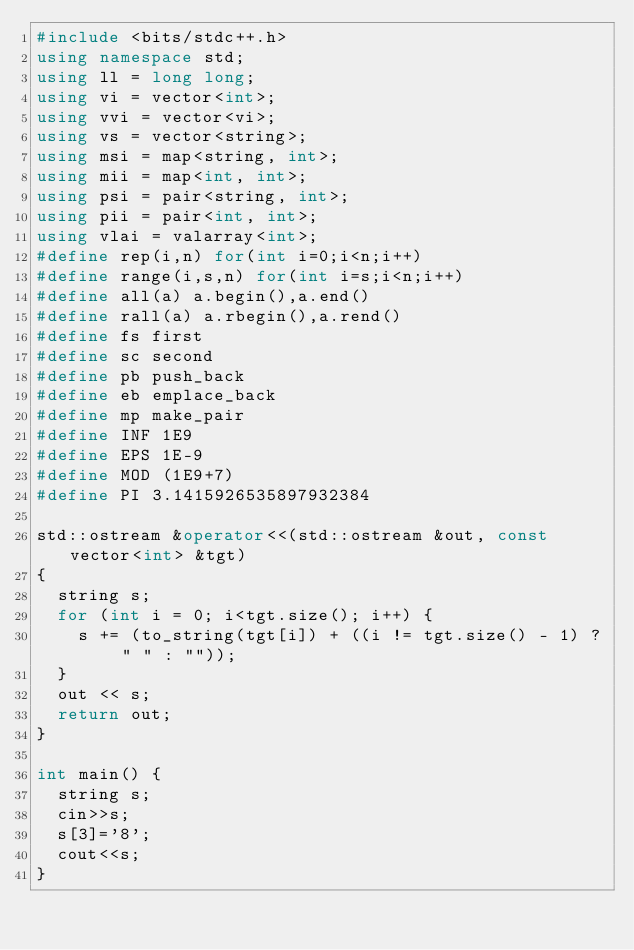Convert code to text. <code><loc_0><loc_0><loc_500><loc_500><_C++_>#include <bits/stdc++.h>
using namespace std;
using ll = long long;
using vi = vector<int>;
using vvi = vector<vi>;
using vs = vector<string>;
using msi = map<string, int>;
using mii = map<int, int>;
using psi = pair<string, int>;
using pii = pair<int, int>;
using vlai = valarray<int>;
#define rep(i,n) for(int i=0;i<n;i++)
#define range(i,s,n) for(int i=s;i<n;i++)
#define all(a) a.begin(),a.end()
#define rall(a) a.rbegin(),a.rend()
#define fs first
#define sc second
#define pb push_back
#define eb emplace_back
#define mp make_pair
#define INF 1E9
#define EPS 1E-9
#define MOD (1E9+7)
#define PI 3.1415926535897932384
 
std::ostream &operator<<(std::ostream &out, const vector<int> &tgt)
{
	string s;
	for (int i = 0; i<tgt.size(); i++) {
		s += (to_string(tgt[i]) + ((i != tgt.size() - 1) ? " " : ""));
	}
	out << s;
	return out;
}
 
int main() {
	string s;
	cin>>s;
	s[3]='8';
	cout<<s;
}</code> 